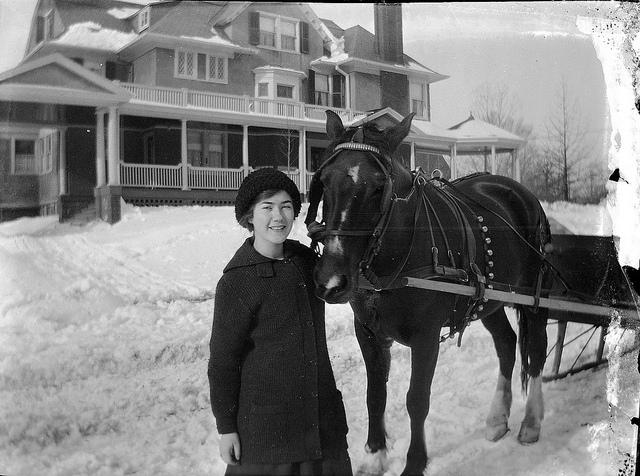Is that horse friendly?
Concise answer only. Yes. Are shadows cast?
Concise answer only. No. Is there snow covering the ground?
Write a very short answer. Yes. How many people are posed?
Answer briefly. 1. What season is it?
Answer briefly. Winter. 